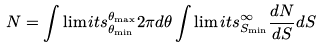Convert formula to latex. <formula><loc_0><loc_0><loc_500><loc_500>N = \int \lim i t s _ { \theta _ { \min } } ^ { \theta _ { \max } } 2 \pi d \theta \int \lim i t s _ { S _ { \min } } ^ { \infty } \frac { d N } { d S } d S</formula> 